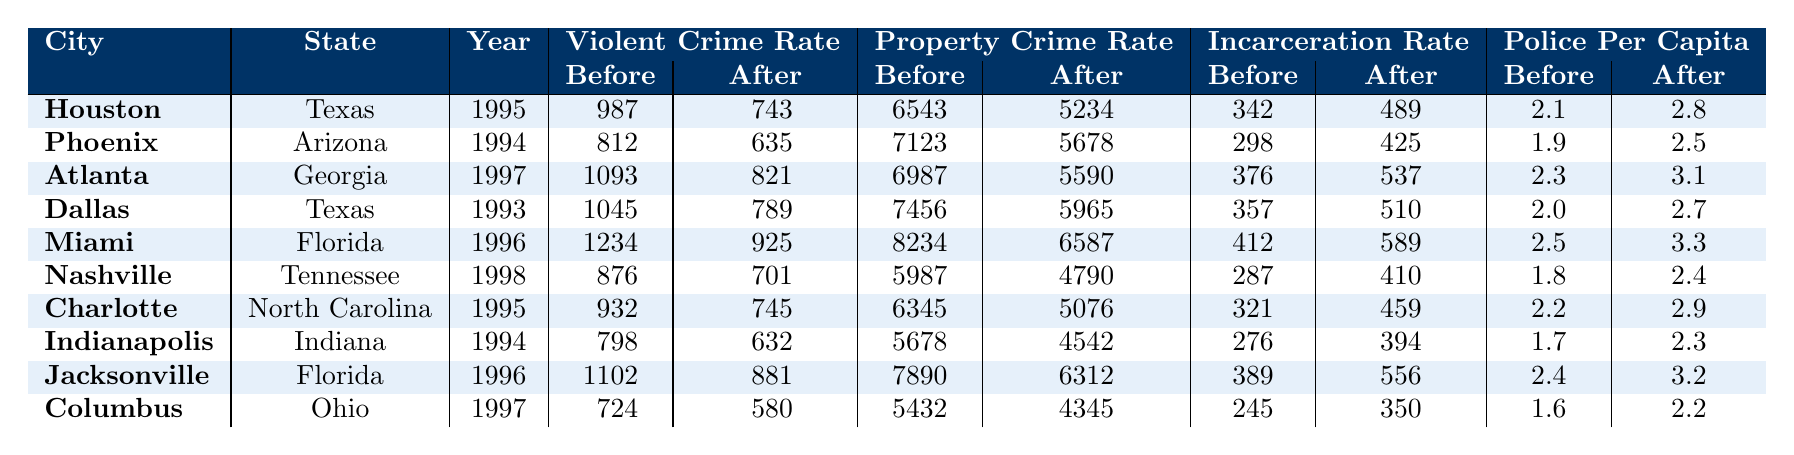What is the violent crime rate in Houston before policy implementation? The table shows that the violent crime rate in Houston before the tough on crime policies was 987.
Answer: 987 What was the property crime rate in Miami after the tough on crime policies were implemented? According to the table, the property crime rate in Miami after implementation was 6587.
Answer: 6587 In which city was the violent crime rate after the policies implemented the lowest? The table indicates that Columbus had the lowest violent crime rate after policies were implemented, which was 580.
Answer: Columbus What was the difference in the incarceration rate in Dallas before and after the policies were implemented? The table shows the incarceration rate in Dallas before was 357 and after was 510. The difference is 510 - 357 = 153.
Answer: 153 Which city had the highest property crime rate before the tough on crime policies? Atlanta had the highest property crime rate before the policies, which was 6987.
Answer: Atlanta What was the average police officers per capita before tough on crime policies across all cities? The before rates for police officers per capita are: 2.1, 1.9, 2.3, 2.0, 2.5, 1.8, 2.2, 1.7, 2.4, and 1.6. The sum is 22.5 and dividing by 10 gives an average of 2.25.
Answer: 2.25 Was there an increase in the violent crime rate in any city after the implementation of tough on crime policies? Looking through the data, it shows that in each city, the violent crime rate decreased after the implementation. Therefore, there was no increase.
Answer: No What is the total decrease in the property crime rate across all cities after the policies were implemented? By calculating the sum of property crime rates before (6543 + 7123 + 6987 + 7456 + 8234 + 5987 + 6345 + 5678 + 7890 + 5432 =  68565) and after (5234 + 5678 + 5590 + 5965 + 6587 + 4790 + 5076 + 4542 + 6312 + 4345 = 51809), the total decrease is 68565 - 51809 = 16756.
Answer: 16756 Which city saw the most significant drop in the violent crime rate? Atlanta had a violent crime rate drop from 1093 to 821, which is a difference of 272. This is the largest drop in the table.
Answer: Atlanta Was the incarceration rate in Nashville before the policies lower than the state average of 350? The incarceration rate in Nashville before policies was 287, which is indeed lower than 350.
Answer: Yes 